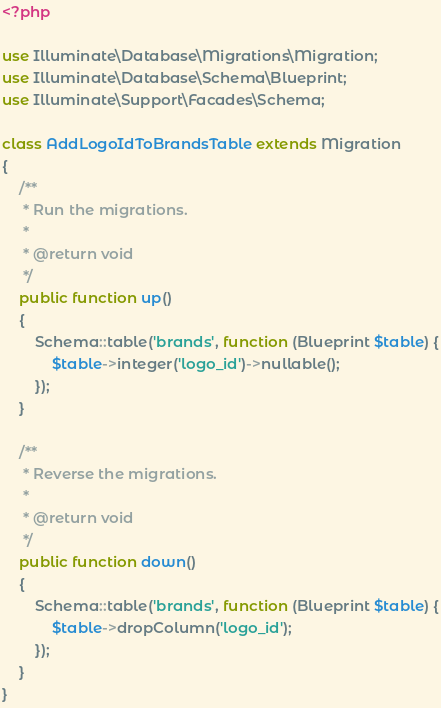<code> <loc_0><loc_0><loc_500><loc_500><_PHP_><?php

use Illuminate\Database\Migrations\Migration;
use Illuminate\Database\Schema\Blueprint;
use Illuminate\Support\Facades\Schema;

class AddLogoIdToBrandsTable extends Migration
{
    /**
     * Run the migrations.
     *
     * @return void
     */
    public function up()
    {
        Schema::table('brands', function (Blueprint $table) {
            $table->integer('logo_id')->nullable(); 
        });
    }

    /**
     * Reverse the migrations.
     *
     * @return void
     */
    public function down()
    {
        Schema::table('brands', function (Blueprint $table) {
            $table->dropColumn('logo_id');
        });
    }
}
</code> 